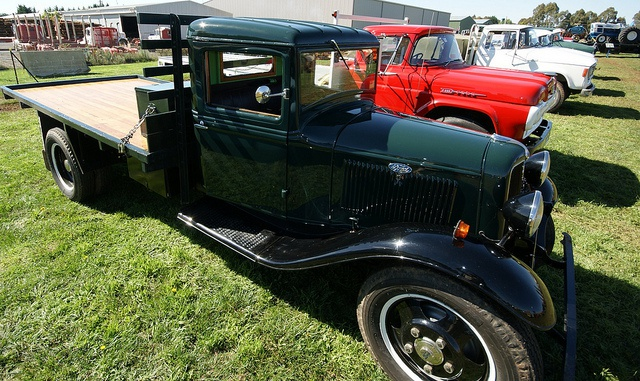Describe the objects in this image and their specific colors. I can see truck in white, black, ivory, gray, and teal tones, truck in white, red, salmon, black, and maroon tones, truck in white, darkgray, gray, and black tones, and truck in white, gray, darkgray, teal, and black tones in this image. 